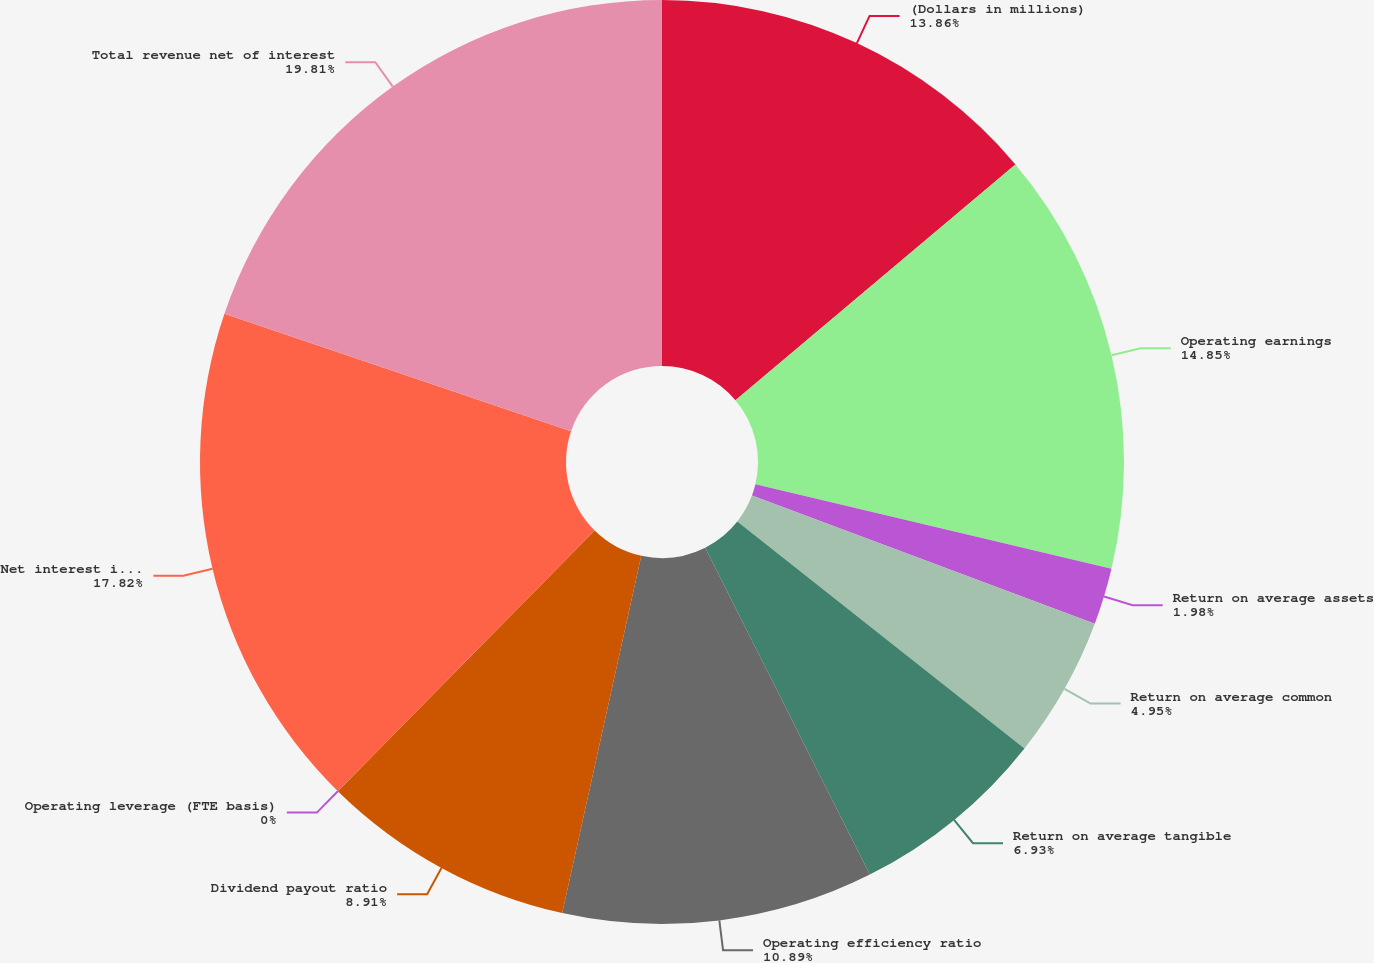Convert chart. <chart><loc_0><loc_0><loc_500><loc_500><pie_chart><fcel>(Dollars in millions)<fcel>Operating earnings<fcel>Return on average assets<fcel>Return on average common<fcel>Return on average tangible<fcel>Operating efficiency ratio<fcel>Dividend payout ratio<fcel>Operating leverage (FTE basis)<fcel>Net interest income<fcel>Total revenue net of interest<nl><fcel>13.86%<fcel>14.85%<fcel>1.98%<fcel>4.95%<fcel>6.93%<fcel>10.89%<fcel>8.91%<fcel>0.0%<fcel>17.82%<fcel>19.8%<nl></chart> 